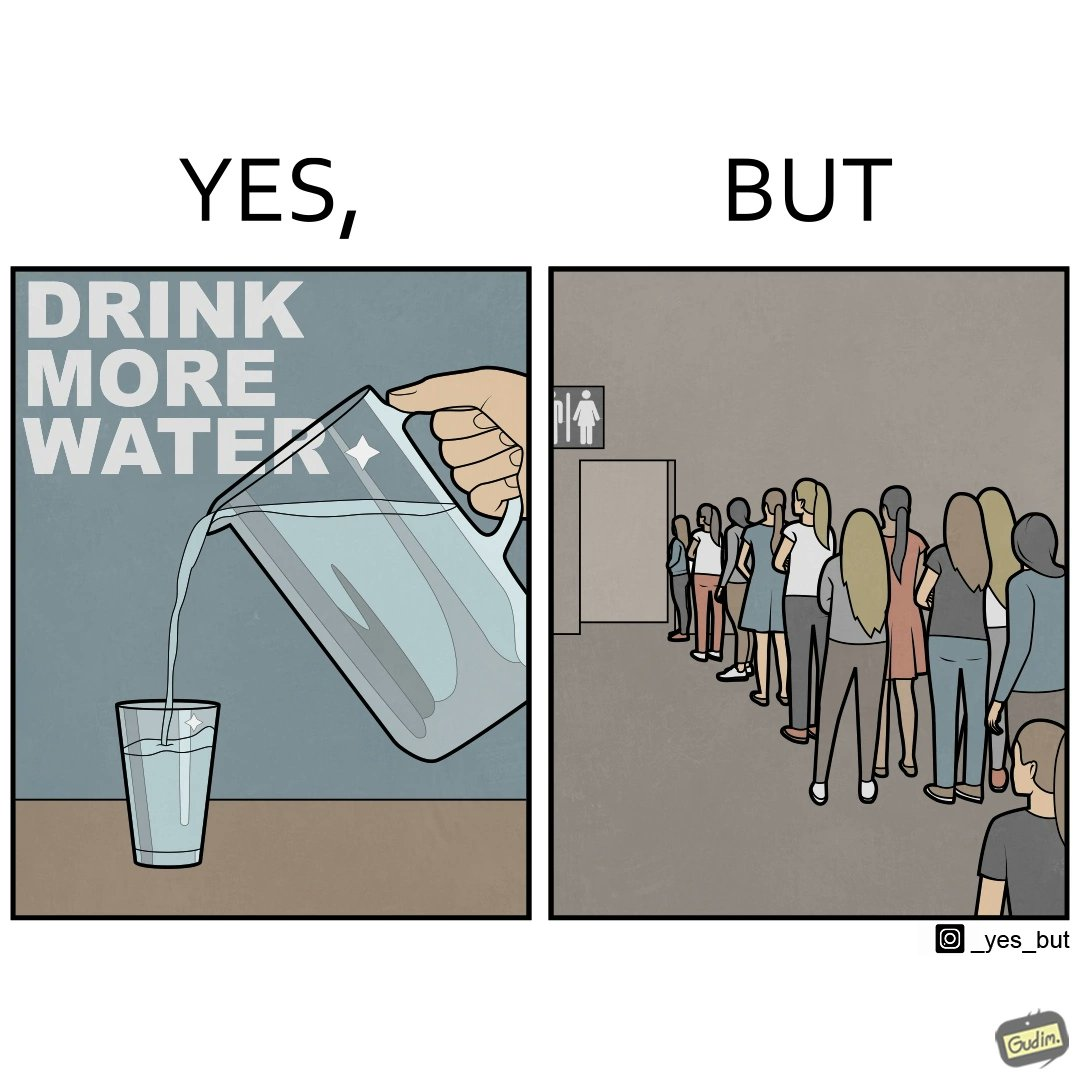Is there satirical content in this image? Yes, this image is satirical. 